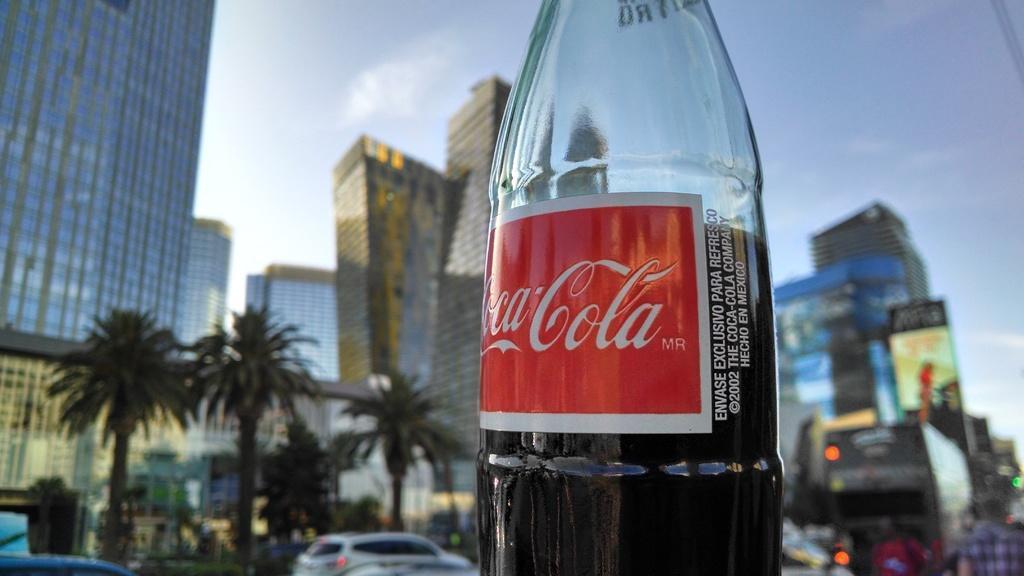Please provide a concise description of this image. There is a plastic bottle in the image with a drink in it. There is also a Coca cola label placed on it. Just beside the label there is some text written on the bottle. In the background there are skyscrapers and trees. In the below right corner there are few people. There are also few cars and a bus in the image. Just above but there is a hoarding. At the top of the image there is sky. 